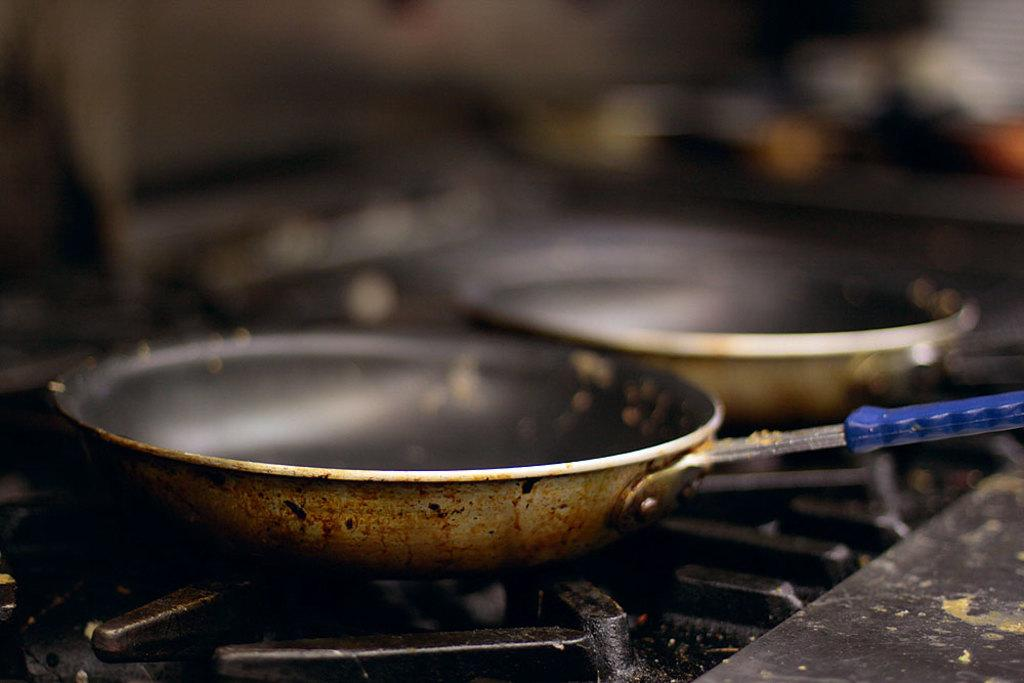How many pans are visible in the image? There are two pans in the image. Where are the pans located in the image? The pans are on a stove. What type of dinner is being prepared in the pans in the image? There is no indication of a dinner being prepared in the image; it only shows two pans on a stove. How many eggs are visible in the image? There are no eggs visible in the image. 